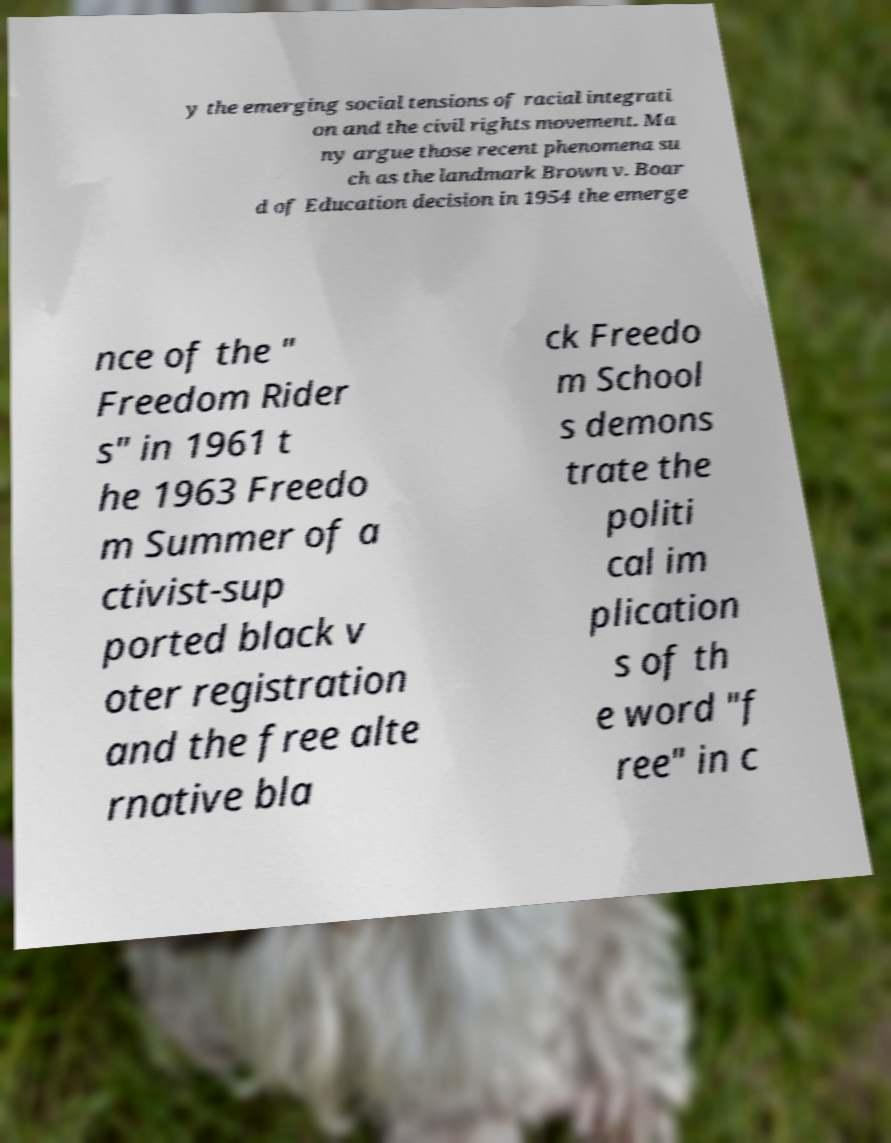There's text embedded in this image that I need extracted. Can you transcribe it verbatim? y the emerging social tensions of racial integrati on and the civil rights movement. Ma ny argue those recent phenomena su ch as the landmark Brown v. Boar d of Education decision in 1954 the emerge nce of the " Freedom Rider s" in 1961 t he 1963 Freedo m Summer of a ctivist-sup ported black v oter registration and the free alte rnative bla ck Freedo m School s demons trate the politi cal im plication s of th e word "f ree" in c 